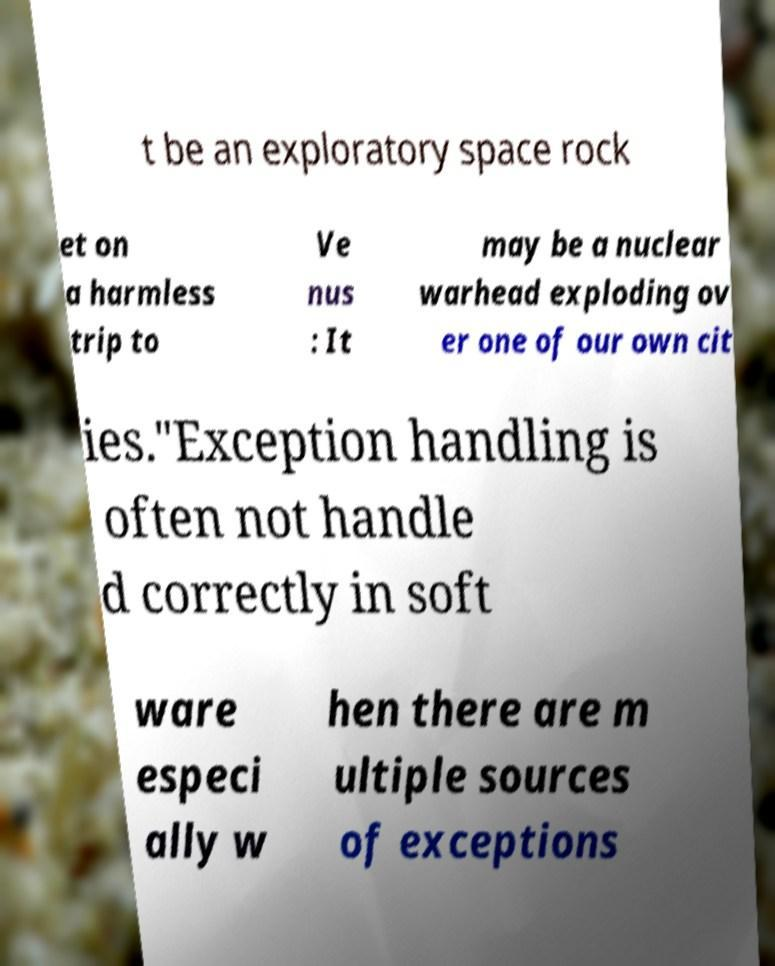Could you assist in decoding the text presented in this image and type it out clearly? t be an exploratory space rock et on a harmless trip to Ve nus : It may be a nuclear warhead exploding ov er one of our own cit ies."Exception handling is often not handle d correctly in soft ware especi ally w hen there are m ultiple sources of exceptions 